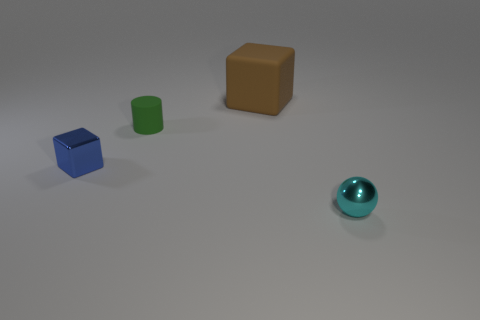Add 2 rubber objects. How many objects exist? 6 Subtract all balls. How many objects are left? 3 Subtract all big yellow matte spheres. Subtract all tiny cyan shiny spheres. How many objects are left? 3 Add 4 brown objects. How many brown objects are left? 5 Add 3 large green rubber blocks. How many large green rubber blocks exist? 3 Subtract 0 red cylinders. How many objects are left? 4 